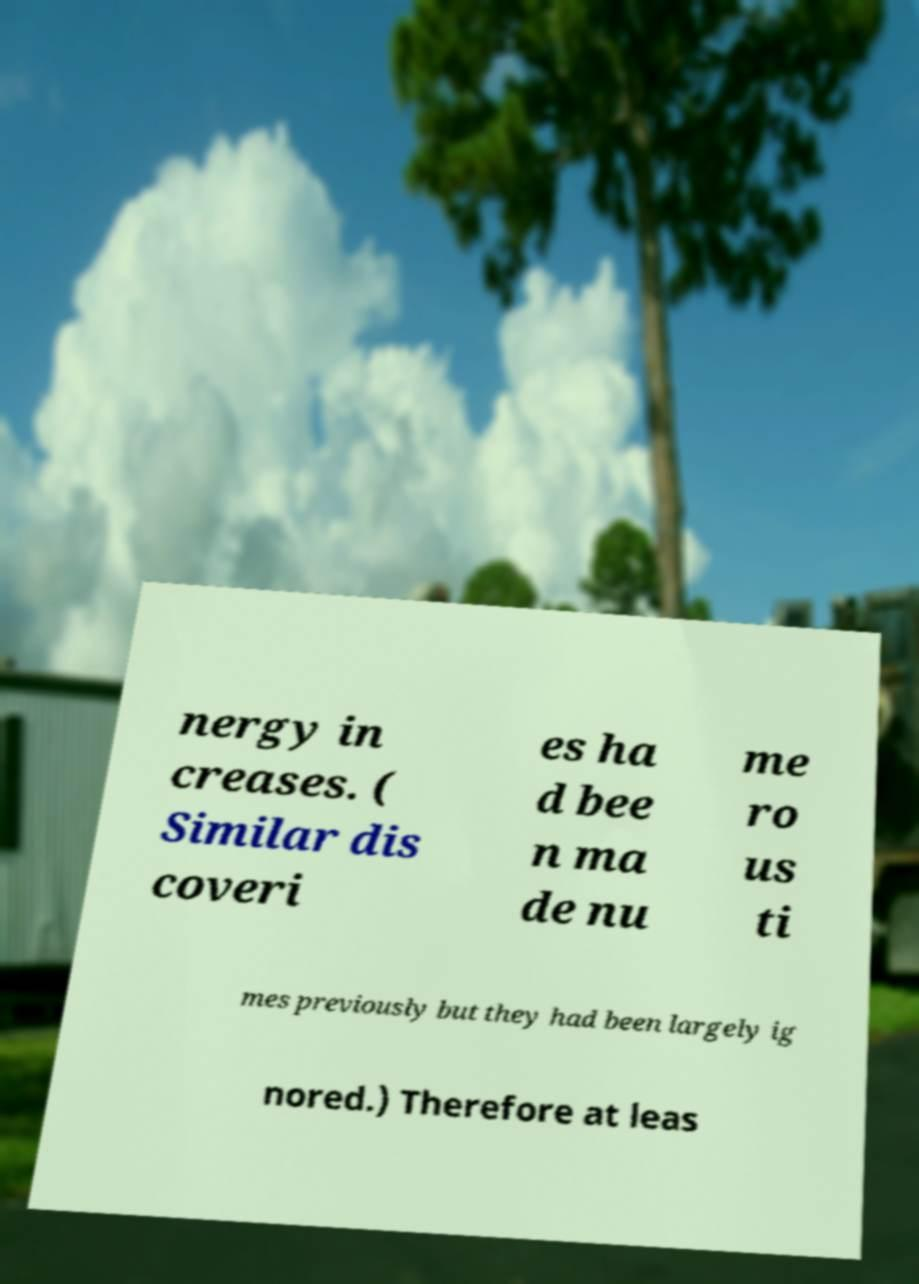There's text embedded in this image that I need extracted. Can you transcribe it verbatim? nergy in creases. ( Similar dis coveri es ha d bee n ma de nu me ro us ti mes previously but they had been largely ig nored.) Therefore at leas 